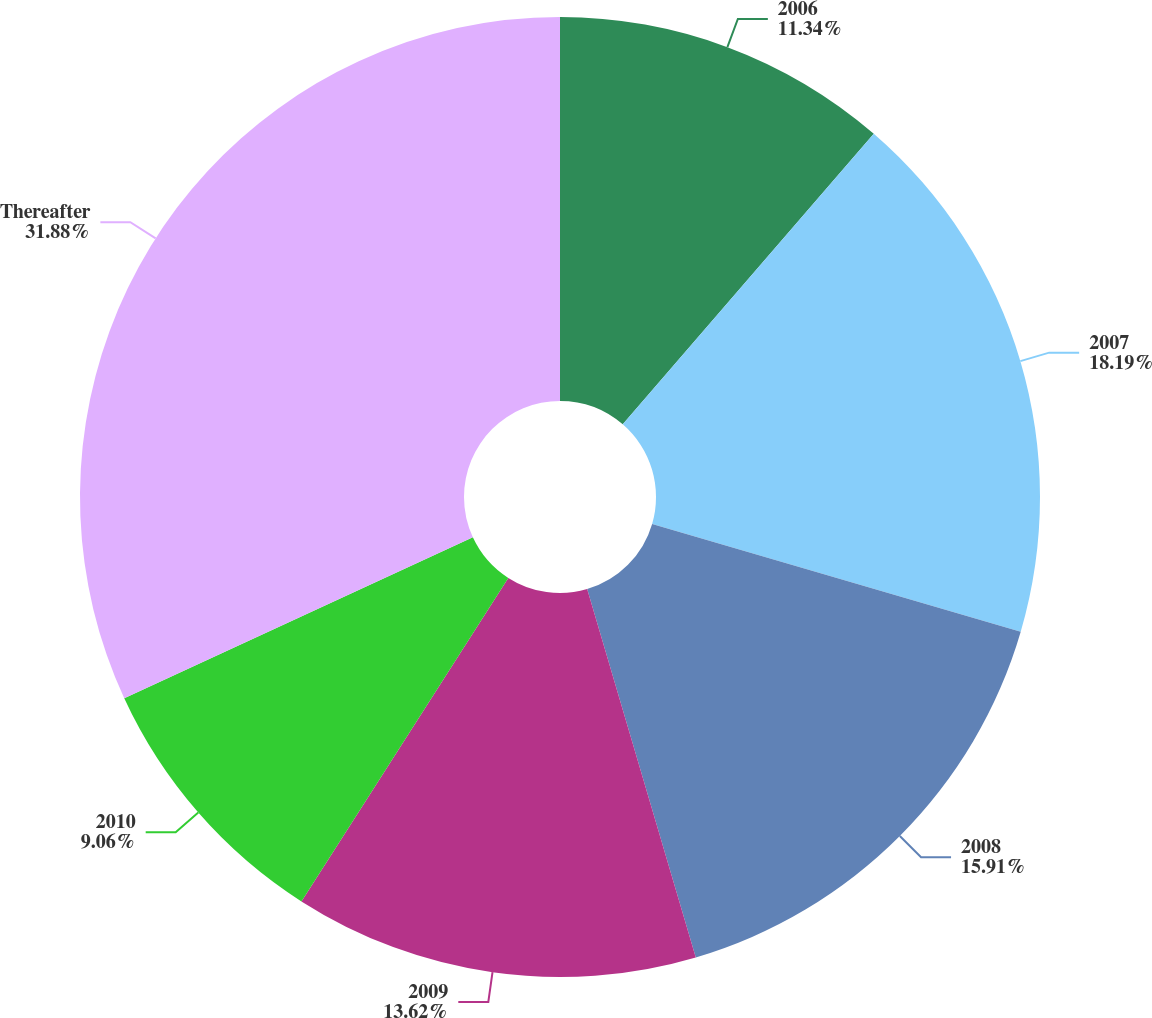Convert chart. <chart><loc_0><loc_0><loc_500><loc_500><pie_chart><fcel>2006<fcel>2007<fcel>2008<fcel>2009<fcel>2010<fcel>Thereafter<nl><fcel>11.34%<fcel>18.19%<fcel>15.91%<fcel>13.62%<fcel>9.06%<fcel>31.89%<nl></chart> 